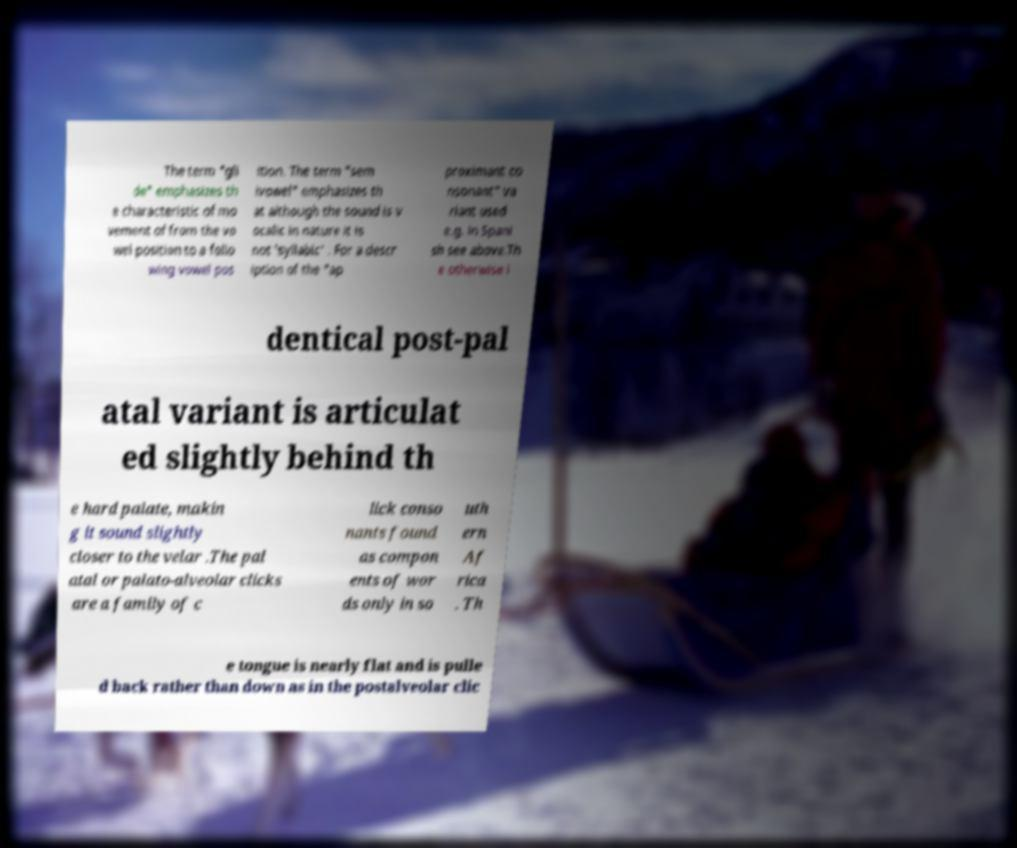I need the written content from this picture converted into text. Can you do that? The term "gli de" emphasizes th e characteristic of mo vement of from the vo wel position to a follo wing vowel pos ition. The term "sem ivowel" emphasizes th at although the sound is v ocalic in nature it is not 'syllabic' . For a descr iption of the "ap proximant co nsonant" va riant used e.g. in Spani sh see above.Th e otherwise i dentical post-pal atal variant is articulat ed slightly behind th e hard palate, makin g it sound slightly closer to the velar .The pal atal or palato-alveolar clicks are a family of c lick conso nants found as compon ents of wor ds only in so uth ern Af rica . Th e tongue is nearly flat and is pulle d back rather than down as in the postalveolar clic 